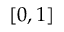Convert formula to latex. <formula><loc_0><loc_0><loc_500><loc_500>[ 0 , 1 ]</formula> 